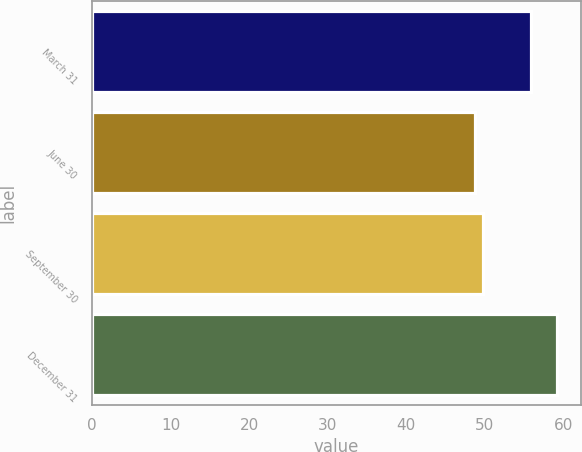<chart> <loc_0><loc_0><loc_500><loc_500><bar_chart><fcel>March 31<fcel>June 30<fcel>September 30<fcel>December 31<nl><fcel>55.89<fcel>48.7<fcel>49.75<fcel>59.23<nl></chart> 